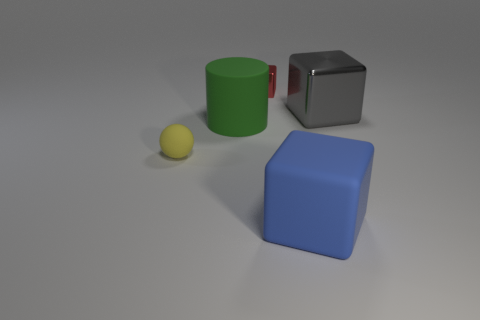Add 3 cubes. How many objects exist? 8 Subtract all blocks. How many objects are left? 2 Add 1 small metal objects. How many small metal objects exist? 2 Subtract 0 red cylinders. How many objects are left? 5 Subtract all small metallic things. Subtract all tiny balls. How many objects are left? 3 Add 5 yellow matte balls. How many yellow matte balls are left? 6 